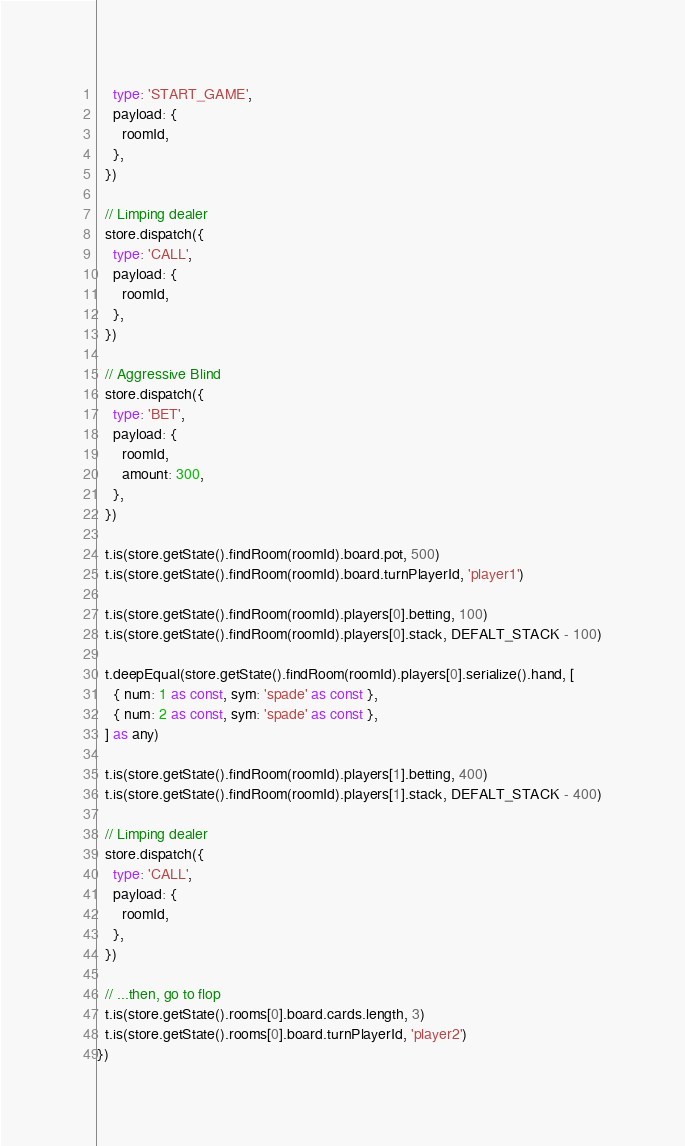<code> <loc_0><loc_0><loc_500><loc_500><_TypeScript_>    type: 'START_GAME',
    payload: {
      roomId,
    },
  })

  // Limping dealer
  store.dispatch({
    type: 'CALL',
    payload: {
      roomId,
    },
  })

  // Aggressive Blind
  store.dispatch({
    type: 'BET',
    payload: {
      roomId,
      amount: 300,
    },
  })

  t.is(store.getState().findRoom(roomId).board.pot, 500)
  t.is(store.getState().findRoom(roomId).board.turnPlayerId, 'player1')

  t.is(store.getState().findRoom(roomId).players[0].betting, 100)
  t.is(store.getState().findRoom(roomId).players[0].stack, DEFALT_STACK - 100)

  t.deepEqual(store.getState().findRoom(roomId).players[0].serialize().hand, [
    { num: 1 as const, sym: 'spade' as const },
    { num: 2 as const, sym: 'spade' as const },
  ] as any)

  t.is(store.getState().findRoom(roomId).players[1].betting, 400)
  t.is(store.getState().findRoom(roomId).players[1].stack, DEFALT_STACK - 400)

  // Limping dealer
  store.dispatch({
    type: 'CALL',
    payload: {
      roomId,
    },
  })

  // ...then, go to flop
  t.is(store.getState().rooms[0].board.cards.length, 3)
  t.is(store.getState().rooms[0].board.turnPlayerId, 'player2')
})
</code> 